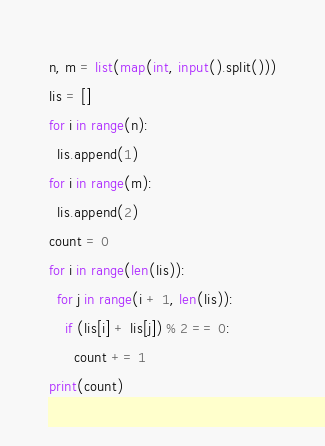Convert code to text. <code><loc_0><loc_0><loc_500><loc_500><_Python_>n, m = list(map(int, input().split()))
lis = []
for i in range(n):
  lis.append(1)
for i in range(m):
  lis.append(2)
count = 0
for i in range(len(lis)):
  for j in range(i + 1, len(lis)):
    if (lis[i] + lis[j]) % 2 == 0:
      count += 1
print(count)</code> 